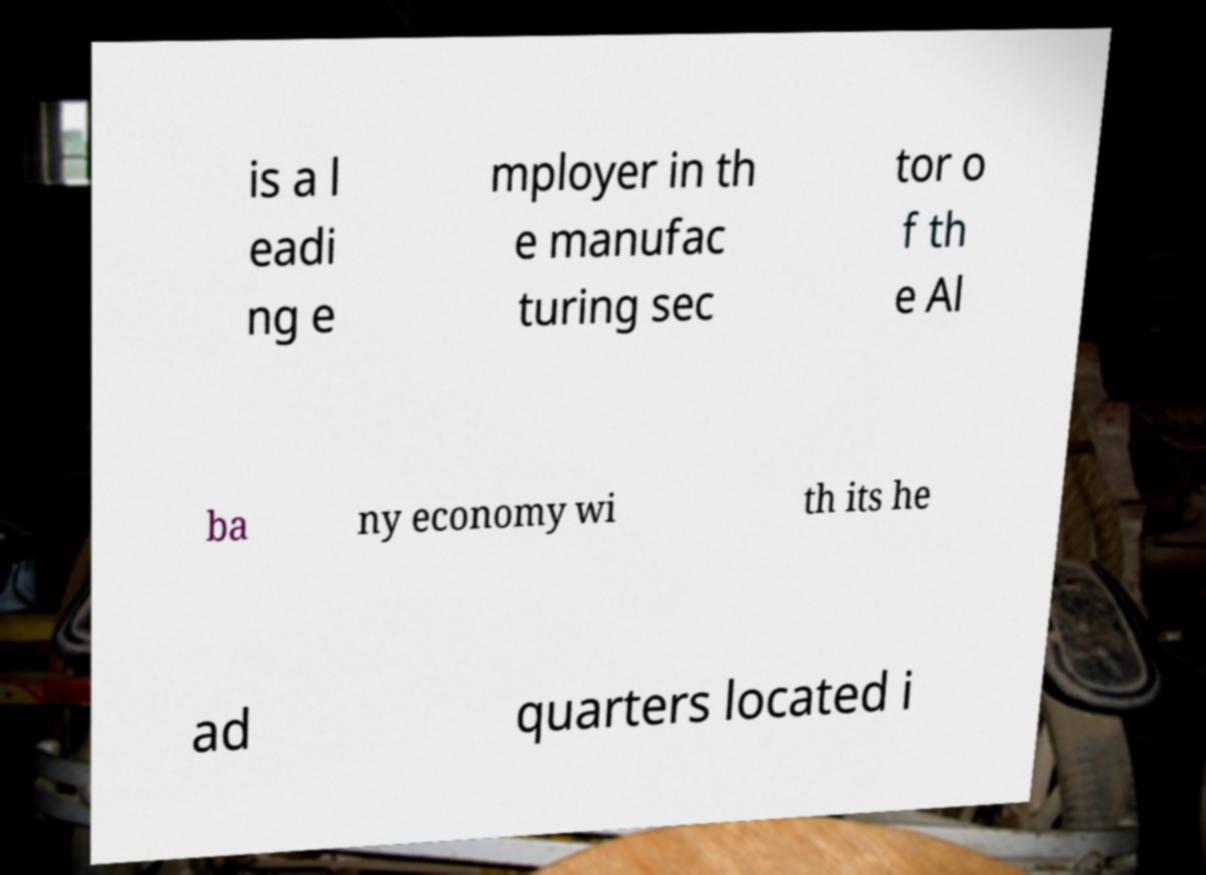I need the written content from this picture converted into text. Can you do that? is a l eadi ng e mployer in th e manufac turing sec tor o f th e Al ba ny economy wi th its he ad quarters located i 